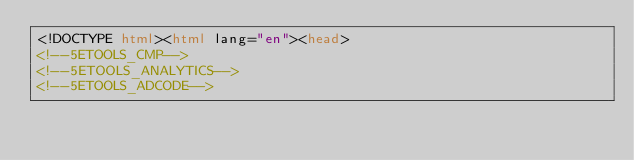Convert code to text. <code><loc_0><loc_0><loc_500><loc_500><_HTML_><!DOCTYPE html><html lang="en"><head>
<!--5ETOOLS_CMP-->
<!--5ETOOLS_ANALYTICS-->
<!--5ETOOLS_ADCODE--></code> 